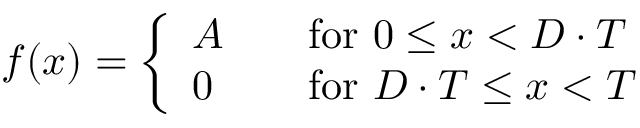<formula> <loc_0><loc_0><loc_500><loc_500>f ( x ) = { \left \{ \begin{array} { l l } { A } & { \quad f o r 0 \leq x < D \cdot T } \\ { 0 } & { \quad f o r D \cdot T \leq x < T } \end{array} }</formula> 